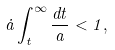Convert formula to latex. <formula><loc_0><loc_0><loc_500><loc_500>\dot { a } \int _ { t } ^ { \infty } \frac { d t } { a } < 1 ,</formula> 